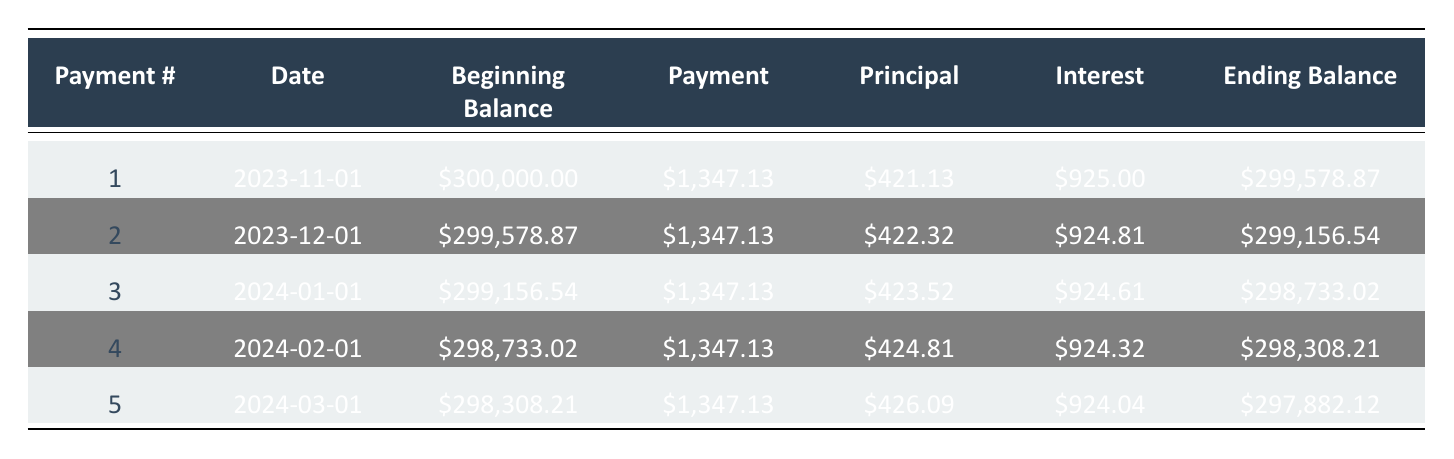What is the scheduled payment for the first month? The scheduled payment for the first month is directly listed in the table under the "Payment" column for Payment #1, which is $1,347.13.
Answer: $1,347.13 How much of the first payment is applied to the principal? The table shows the amount applied to the principal payment for Payment #1, which is $421.13.
Answer: $421.13 What is the ending balance after the second payment? The ending balance after the second payment is provided in the table under the "Ending Balance" column for Payment #2, which is $299,156.54.
Answer: $299,156.54 Is the principal payment in the first month greater than the principal payment in the second month? To answer this, we compare the principal payment for Payment #1 ($421.13) and Payment #2 ($422.32), and since $421.13 is less than $422.32, the statement is false.
Answer: No What is the total interest payment made in the first three months? The table shows the interest payments for the first three months: $925.00 (Month 1) + $924.81 (Month 2) + $924.61 (Month 3). Adding these amounts results in $2,774.42.
Answer: $2,774.42 What is the difference between the beginning balance of the first payment and the ending balance of the first payment? The beginning balance for the first payment is $300,000.00 and the ending balance of the first payment is $299,578.87. The difference is calculated as $300,000.00 - $299,578.87 = $421.13.
Answer: $421.13 What is the average principal payment for the first five payments? The principal payments for the first five months are $421.13, $422.32, $423.52, $424.81, and $426.09. Adding these values gives a total of $2,417.87. Dividing by 5 results in an average principal payment of $483.57.
Answer: $483.57 Is the scheduled payment constant throughout the first five payments? The scheduled payment is the same for all five payments at $1,347.13, as indicated in the "Payment" column. Therefore, the statement is true.
Answer: Yes If the mortgage had a lower interest rate, would the principal payments generally be higher? It is known that lower interest rates typically lead to larger portions of the payment being applied towards the principal; thus, if the interest rate was lower, the principal payments would likely be higher, confirming the statement as true.
Answer: Yes 